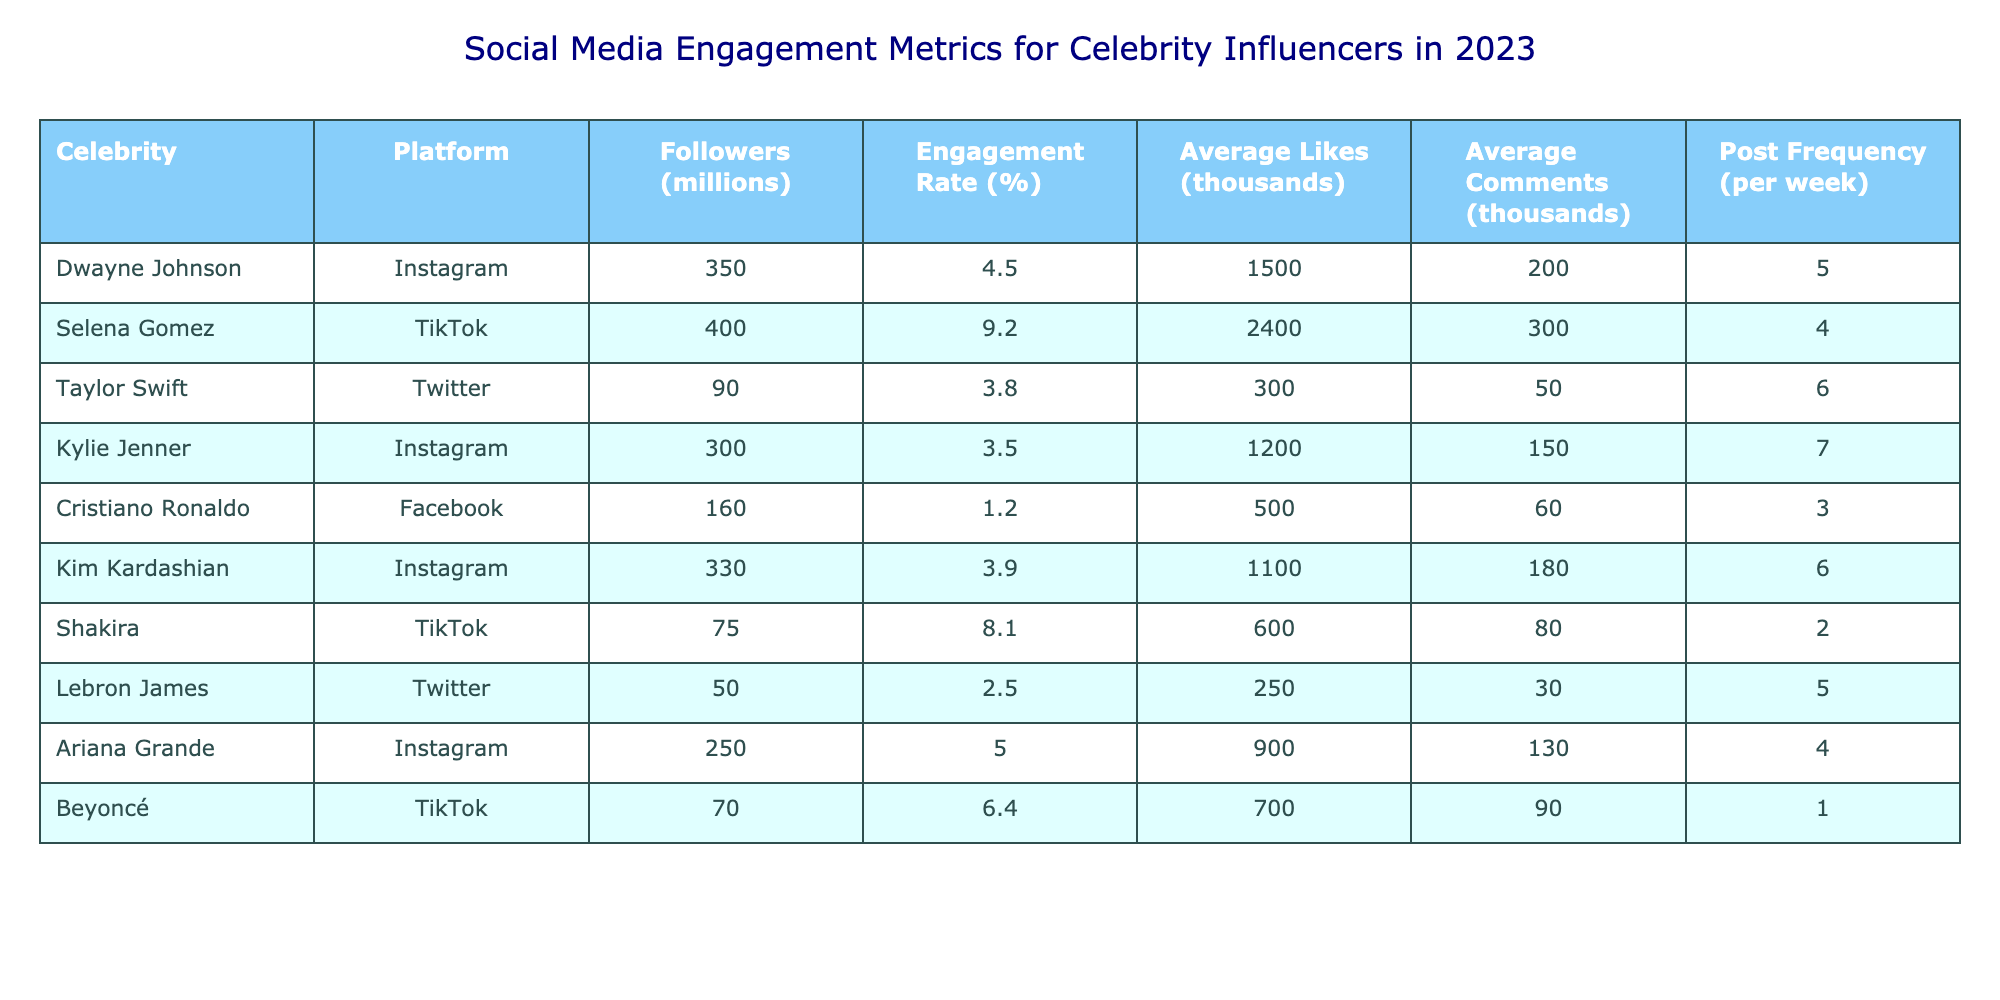What is the engagement rate for Selena Gomez on TikTok? The engagement rate for Selena Gomez is listed directly in the table under the "Engagement Rate (%)" column for the TikTok row. It shows 9.2%.
Answer: 9.2% How many average likes does Dwayne Johnson get on Instagram? In the table, for Dwayne Johnson's row under Instagram, the "Average Likes (thousands)" column indicates he gets 1500 average likes.
Answer: 1500 Which celebrity has the highest number of followers, and on which platform? By checking the "Followers (millions)" column, Selena Gomez has the highest number of followers at 400 million on TikTok.
Answer: Selena Gomez, TikTok What is the difference in average comments between Kim Kardashian and Ariana Grande on Instagram? The average comments for Kim Kardashian on Instagram are 180 (from her row), and for Ariana Grande, it is 130. The difference is calculated as 180 - 130 = 50.
Answer: 50 Is Ariana Grande's engagement rate higher than that of Taylor Swift? Ariana Grande has an engagement rate of 5.0%, while Taylor Swift has an engagement rate of 3.8%. Since 5.0% > 3.8%, the answer is yes.
Answer: Yes What is the average post frequency among the celebrities listed? To find the average post frequency, sum the Post Frequency column (5 + 4 + 6 + 7 + 3 + 6 + 2 + 5 + 4 + 1 = 43) and divide by the number of celebrities (10). The average is 43/10 = 4.3 posts per week.
Answer: 4.3 Is it true that Cristiano Ronaldo has an engagement rate lower than 2%? The engagement rate for Cristiano Ronaldo is listed as 1.2%, which is indeed lower than 2%. Therefore, the statement is true.
Answer: True What are the average likes for TikTok celebrities compared to Instagram celebrities? TikTok average likes are (2400 + 600 + 700) / 3 = 900. Instagram average likes are (1500 + 1200 + 1100 + 900) / 4 = 1175. Since 900 (TikTok) < 1175 (Instagram), Instagram celebrities have higher average likes.
Answer: Instagram higher Who posts more frequently, Kylie Jenner or Shakira? Kylie Jenner's post frequency is 7 per week while Shakira's frequency is only 2 per week. Since 7 > 2, Kylie Jenner posts more frequently than Shakira.
Answer: Kylie Jenner 